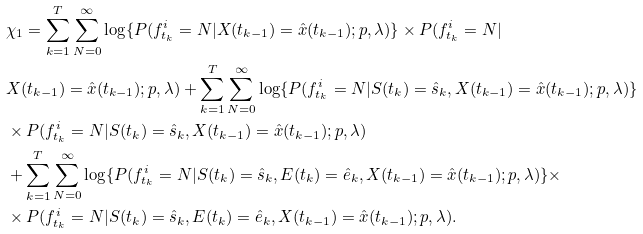Convert formula to latex. <formula><loc_0><loc_0><loc_500><loc_500>& \chi _ { 1 } = \sum _ { k = 1 } ^ { T } \sum _ { N = 0 } ^ { \infty } \log \{ P ( f ^ { i } _ { t _ { k } } = N | X ( t _ { k - 1 } ) = \hat { x } ( t _ { k - 1 } ) ; p , \lambda ) \} \times P ( f ^ { i } _ { t _ { k } } = N | \\ & X ( t _ { k - 1 } ) = \hat { x } ( t _ { k - 1 } ) ; p , \lambda ) + \sum _ { k = 1 } ^ { T } \sum _ { N = 0 } ^ { \infty } \log \{ P ( f ^ { i } _ { t _ { k } } = N | S ( t _ { k } ) = \hat { s } _ { k } , X ( t _ { k - 1 } ) = \hat { x } ( t _ { k - 1 } ) ; p , \lambda ) \} \\ & \times P ( f ^ { i } _ { t _ { k } } = N | S ( t _ { k } ) = \hat { s } _ { k } , X ( t _ { k - 1 } ) = \hat { x } ( t _ { k - 1 } ) ; p , \lambda ) \\ & + \sum _ { k = 1 } ^ { T } \sum _ { N = 0 } ^ { \infty } \log \{ P ( f ^ { i } _ { t _ { k } } = N | S ( t _ { k } ) = \hat { s } _ { k } , E ( t _ { k } ) = \hat { e } _ { k } , X ( t _ { k - 1 } ) = \hat { x } ( t _ { k - 1 } ) ; p , \lambda ) \} \times \\ & \times P ( f ^ { i } _ { t _ { k } } = N | S ( t _ { k } ) = \hat { s } _ { k } , E ( t _ { k } ) = \hat { e } _ { k } , X ( t _ { k - 1 } ) = \hat { x } ( t _ { k - 1 } ) ; p , \lambda ) .</formula> 